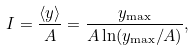Convert formula to latex. <formula><loc_0><loc_0><loc_500><loc_500>I = \frac { \langle y \rangle } { A } = \frac { y _ { \max } } { A \ln ( y _ { \max } / A ) } ,</formula> 